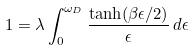<formula> <loc_0><loc_0><loc_500><loc_500>1 = \lambda \int _ { 0 } ^ { \omega _ { D } } \frac { \tanh ( \beta \epsilon / 2 ) } { \epsilon } \, d \epsilon</formula> 